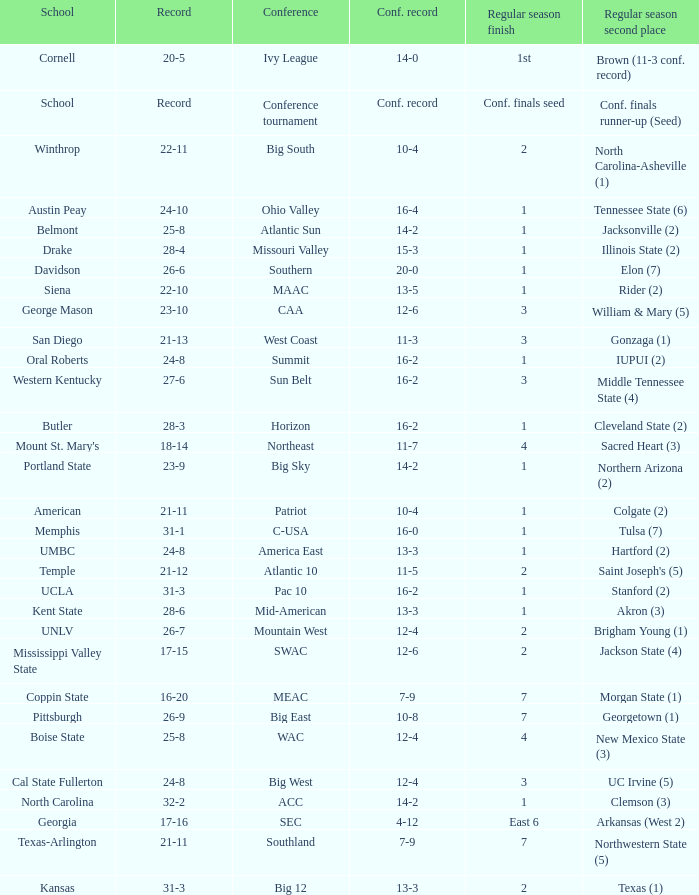For teams in the sun belt conference, what is the conference performance? 16-2. 